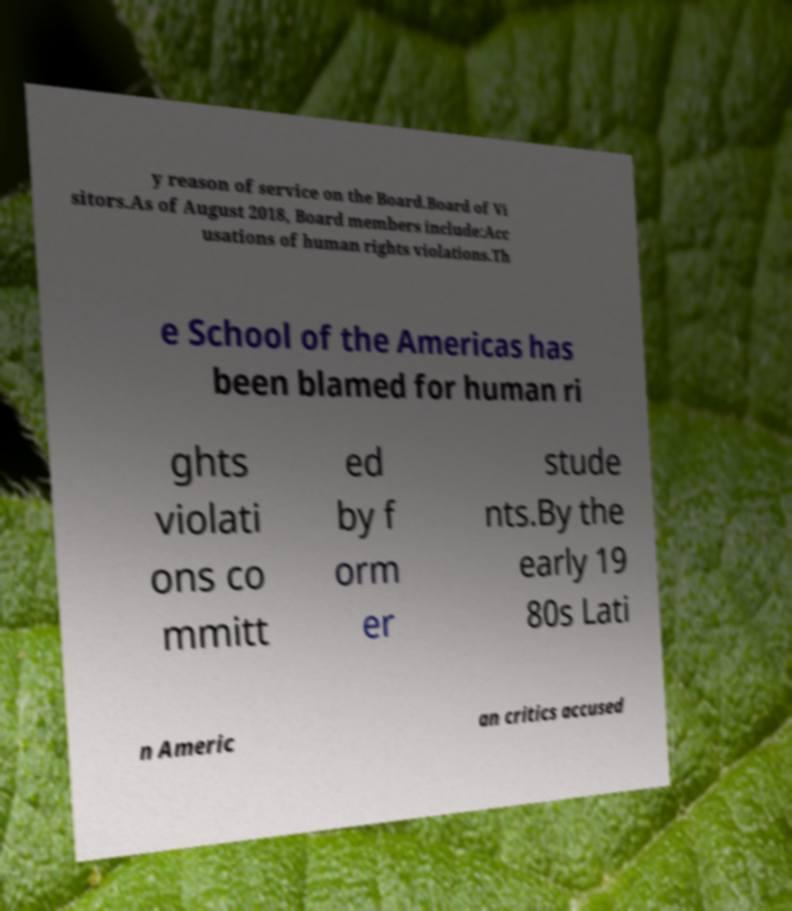For documentation purposes, I need the text within this image transcribed. Could you provide that? y reason of service on the Board.Board of Vi sitors.As of August 2018, Board members include:Acc usations of human rights violations.Th e School of the Americas has been blamed for human ri ghts violati ons co mmitt ed by f orm er stude nts.By the early 19 80s Lati n Americ an critics accused 